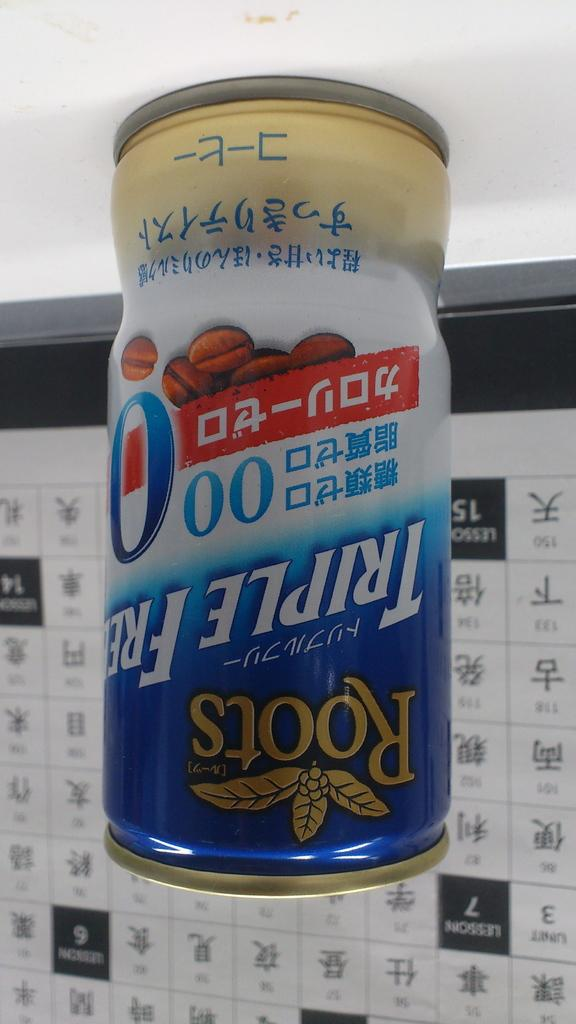<image>
Give a short and clear explanation of the subsequent image. the word Roots that is on some kind of can 